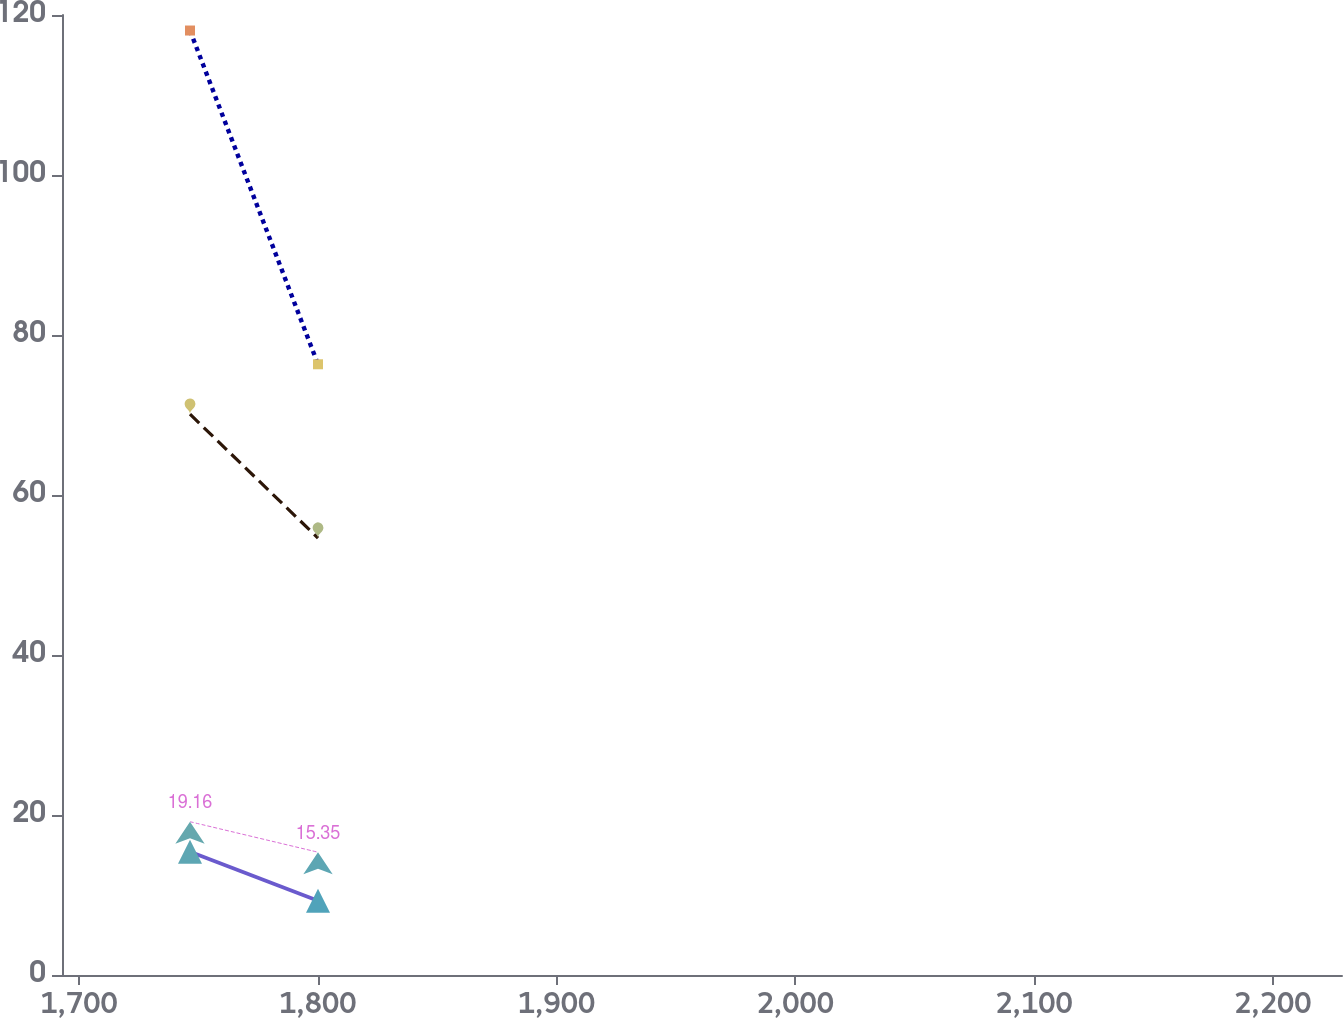Convert chart to OTSL. <chart><loc_0><loc_0><loc_500><loc_500><line_chart><ecel><fcel>Ameren Illinois<fcel>Ameren Missouri<fcel>Ameren (a)<fcel>Genco<nl><fcel>1746.53<fcel>118.06<fcel>70.1<fcel>19.16<fcel>15.4<nl><fcel>1800.14<fcel>76.34<fcel>54.62<fcel>15.35<fcel>9.29<nl><fcel>2282.62<fcel>157.05<fcel>71.71<fcel>25.5<fcel>27.05<nl></chart> 